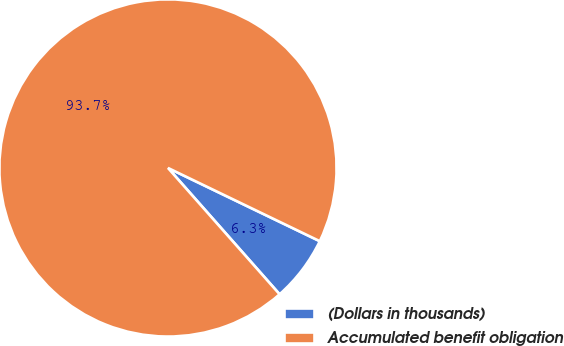Convert chart. <chart><loc_0><loc_0><loc_500><loc_500><pie_chart><fcel>(Dollars in thousands)<fcel>Accumulated benefit obligation<nl><fcel>6.33%<fcel>93.67%<nl></chart> 